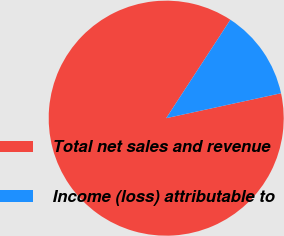<chart> <loc_0><loc_0><loc_500><loc_500><pie_chart><fcel>Total net sales and revenue<fcel>Income (loss) attributable to<nl><fcel>87.6%<fcel>12.4%<nl></chart> 